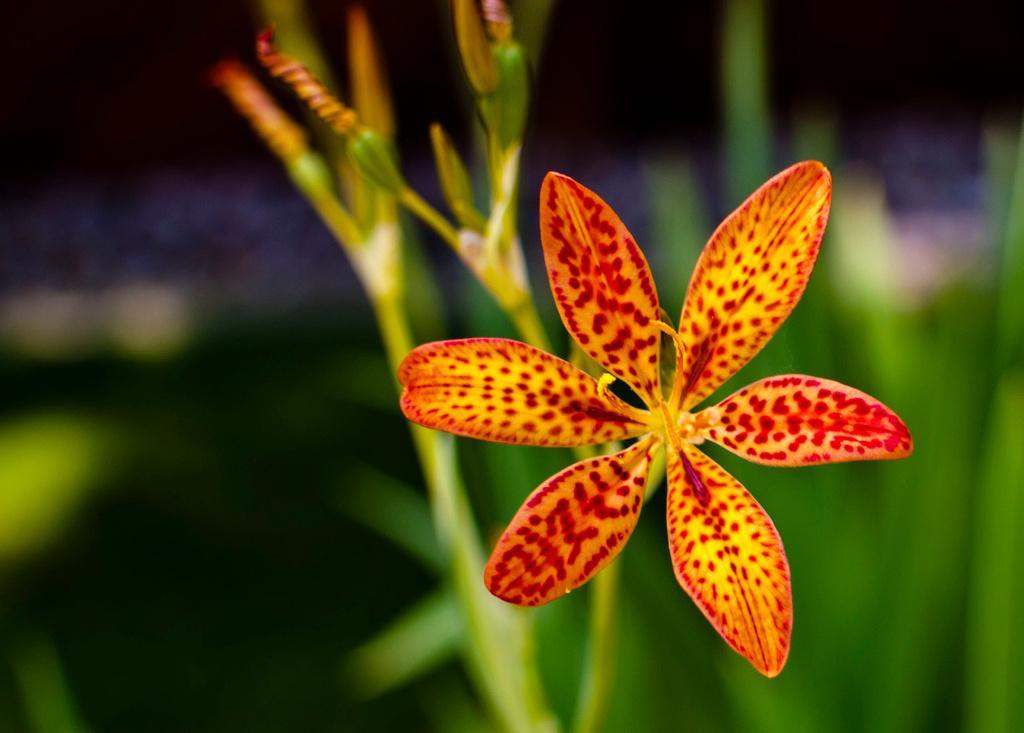Can you describe this image briefly? This image is a zoom in picture of a plant, as we can see there is one flower on the right side of this image. 